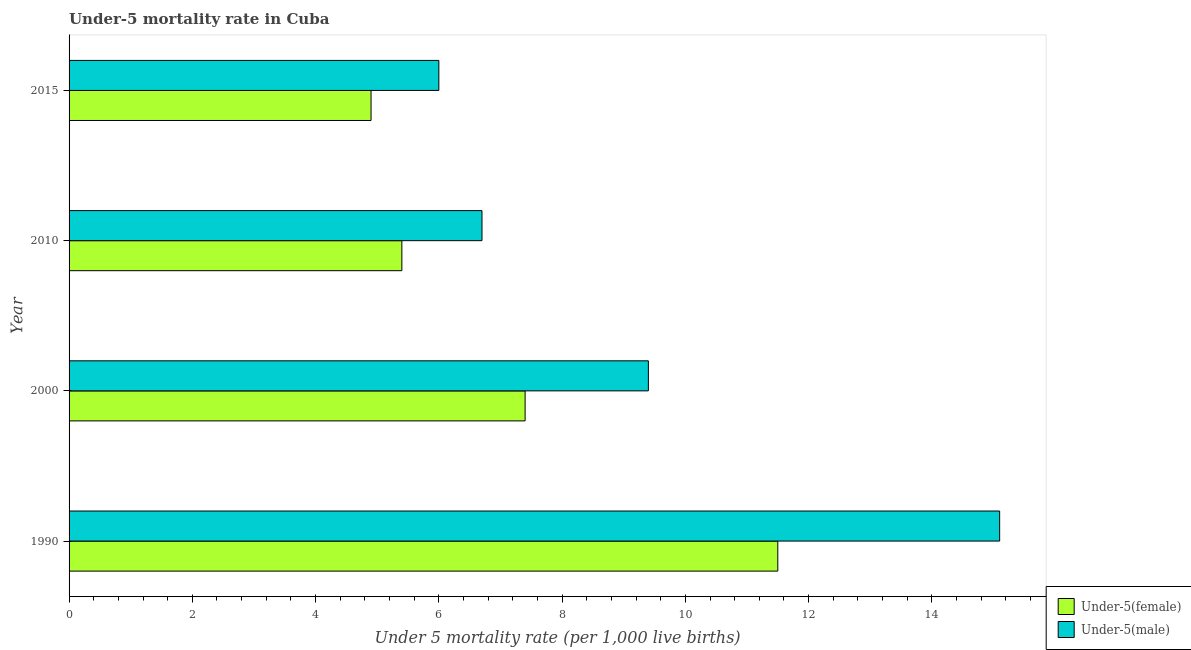Are the number of bars on each tick of the Y-axis equal?
Offer a terse response. Yes. How many bars are there on the 4th tick from the bottom?
Your answer should be compact. 2. What is the label of the 1st group of bars from the top?
Provide a short and direct response. 2015. In how many cases, is the number of bars for a given year not equal to the number of legend labels?
Your answer should be compact. 0. In which year was the under-5 male mortality rate maximum?
Offer a terse response. 1990. In which year was the under-5 female mortality rate minimum?
Provide a short and direct response. 2015. What is the total under-5 male mortality rate in the graph?
Provide a succinct answer. 37.2. What is the difference between the under-5 female mortality rate in 2010 and the under-5 male mortality rate in 2015?
Keep it short and to the point. -0.6. What is the average under-5 female mortality rate per year?
Ensure brevity in your answer.  7.3. In how many years, is the under-5 female mortality rate greater than 6.4 ?
Ensure brevity in your answer.  2. What is the ratio of the under-5 female mortality rate in 2000 to that in 2015?
Offer a terse response. 1.51. Is the under-5 female mortality rate in 1990 less than that in 2010?
Provide a succinct answer. No. Is the difference between the under-5 male mortality rate in 1990 and 2000 greater than the difference between the under-5 female mortality rate in 1990 and 2000?
Your answer should be very brief. Yes. What is the difference between the highest and the second highest under-5 female mortality rate?
Your answer should be very brief. 4.1. Is the sum of the under-5 female mortality rate in 1990 and 2000 greater than the maximum under-5 male mortality rate across all years?
Offer a very short reply. Yes. What does the 2nd bar from the top in 1990 represents?
Keep it short and to the point. Under-5(female). What does the 2nd bar from the bottom in 2015 represents?
Your response must be concise. Under-5(male). How many bars are there?
Make the answer very short. 8. What is the difference between two consecutive major ticks on the X-axis?
Offer a terse response. 2. Does the graph contain any zero values?
Provide a short and direct response. No. Does the graph contain grids?
Keep it short and to the point. No. Where does the legend appear in the graph?
Make the answer very short. Bottom right. What is the title of the graph?
Your answer should be compact. Under-5 mortality rate in Cuba. What is the label or title of the X-axis?
Make the answer very short. Under 5 mortality rate (per 1,0 live births). What is the Under 5 mortality rate (per 1,000 live births) of Under-5(male) in 1990?
Offer a terse response. 15.1. What is the Under 5 mortality rate (per 1,000 live births) in Under-5(male) in 2000?
Provide a short and direct response. 9.4. What is the Under 5 mortality rate (per 1,000 live births) of Under-5(female) in 2010?
Keep it short and to the point. 5.4. What is the Under 5 mortality rate (per 1,000 live births) of Under-5(male) in 2010?
Ensure brevity in your answer.  6.7. Across all years, what is the maximum Under 5 mortality rate (per 1,000 live births) in Under-5(female)?
Give a very brief answer. 11.5. Across all years, what is the minimum Under 5 mortality rate (per 1,000 live births) of Under-5(female)?
Provide a short and direct response. 4.9. Across all years, what is the minimum Under 5 mortality rate (per 1,000 live births) in Under-5(male)?
Your response must be concise. 6. What is the total Under 5 mortality rate (per 1,000 live births) in Under-5(female) in the graph?
Make the answer very short. 29.2. What is the total Under 5 mortality rate (per 1,000 live births) of Under-5(male) in the graph?
Your answer should be very brief. 37.2. What is the difference between the Under 5 mortality rate (per 1,000 live births) in Under-5(female) in 1990 and that in 2000?
Offer a terse response. 4.1. What is the difference between the Under 5 mortality rate (per 1,000 live births) of Under-5(female) in 1990 and that in 2010?
Provide a succinct answer. 6.1. What is the difference between the Under 5 mortality rate (per 1,000 live births) in Under-5(male) in 1990 and that in 2010?
Make the answer very short. 8.4. What is the difference between the Under 5 mortality rate (per 1,000 live births) in Under-5(female) in 1990 and that in 2015?
Make the answer very short. 6.6. What is the difference between the Under 5 mortality rate (per 1,000 live births) of Under-5(male) in 1990 and that in 2015?
Keep it short and to the point. 9.1. What is the difference between the Under 5 mortality rate (per 1,000 live births) in Under-5(female) in 2000 and that in 2010?
Your response must be concise. 2. What is the difference between the Under 5 mortality rate (per 1,000 live births) in Under-5(female) in 2000 and that in 2015?
Ensure brevity in your answer.  2.5. What is the difference between the Under 5 mortality rate (per 1,000 live births) of Under-5(female) in 2010 and that in 2015?
Give a very brief answer. 0.5. What is the difference between the Under 5 mortality rate (per 1,000 live births) in Under-5(female) in 1990 and the Under 5 mortality rate (per 1,000 live births) in Under-5(male) in 2010?
Provide a succinct answer. 4.8. What is the difference between the Under 5 mortality rate (per 1,000 live births) in Under-5(female) in 2000 and the Under 5 mortality rate (per 1,000 live births) in Under-5(male) in 2015?
Offer a very short reply. 1.4. What is the average Under 5 mortality rate (per 1,000 live births) of Under-5(female) per year?
Ensure brevity in your answer.  7.3. In the year 2000, what is the difference between the Under 5 mortality rate (per 1,000 live births) in Under-5(female) and Under 5 mortality rate (per 1,000 live births) in Under-5(male)?
Provide a short and direct response. -2. In the year 2015, what is the difference between the Under 5 mortality rate (per 1,000 live births) of Under-5(female) and Under 5 mortality rate (per 1,000 live births) of Under-5(male)?
Ensure brevity in your answer.  -1.1. What is the ratio of the Under 5 mortality rate (per 1,000 live births) in Under-5(female) in 1990 to that in 2000?
Provide a short and direct response. 1.55. What is the ratio of the Under 5 mortality rate (per 1,000 live births) in Under-5(male) in 1990 to that in 2000?
Your answer should be very brief. 1.61. What is the ratio of the Under 5 mortality rate (per 1,000 live births) of Under-5(female) in 1990 to that in 2010?
Keep it short and to the point. 2.13. What is the ratio of the Under 5 mortality rate (per 1,000 live births) in Under-5(male) in 1990 to that in 2010?
Offer a terse response. 2.25. What is the ratio of the Under 5 mortality rate (per 1,000 live births) in Under-5(female) in 1990 to that in 2015?
Make the answer very short. 2.35. What is the ratio of the Under 5 mortality rate (per 1,000 live births) of Under-5(male) in 1990 to that in 2015?
Offer a terse response. 2.52. What is the ratio of the Under 5 mortality rate (per 1,000 live births) of Under-5(female) in 2000 to that in 2010?
Give a very brief answer. 1.37. What is the ratio of the Under 5 mortality rate (per 1,000 live births) of Under-5(male) in 2000 to that in 2010?
Your answer should be very brief. 1.4. What is the ratio of the Under 5 mortality rate (per 1,000 live births) of Under-5(female) in 2000 to that in 2015?
Ensure brevity in your answer.  1.51. What is the ratio of the Under 5 mortality rate (per 1,000 live births) in Under-5(male) in 2000 to that in 2015?
Keep it short and to the point. 1.57. What is the ratio of the Under 5 mortality rate (per 1,000 live births) in Under-5(female) in 2010 to that in 2015?
Keep it short and to the point. 1.1. What is the ratio of the Under 5 mortality rate (per 1,000 live births) in Under-5(male) in 2010 to that in 2015?
Your answer should be compact. 1.12. What is the difference between the highest and the second highest Under 5 mortality rate (per 1,000 live births) in Under-5(male)?
Give a very brief answer. 5.7. What is the difference between the highest and the lowest Under 5 mortality rate (per 1,000 live births) in Under-5(female)?
Provide a short and direct response. 6.6. What is the difference between the highest and the lowest Under 5 mortality rate (per 1,000 live births) of Under-5(male)?
Make the answer very short. 9.1. 